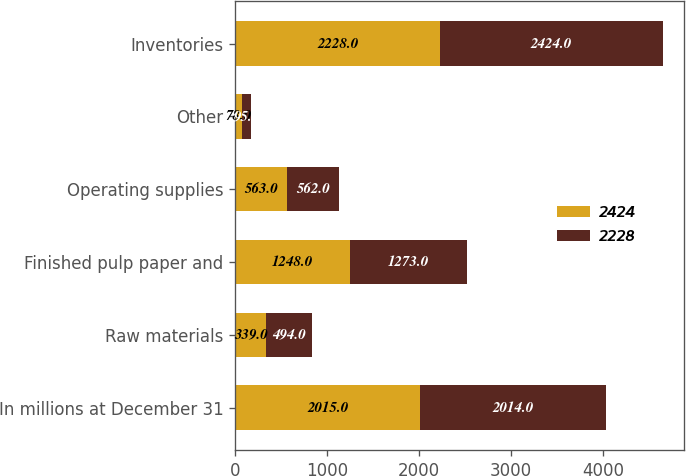Convert chart to OTSL. <chart><loc_0><loc_0><loc_500><loc_500><stacked_bar_chart><ecel><fcel>In millions at December 31<fcel>Raw materials<fcel>Finished pulp paper and<fcel>Operating supplies<fcel>Other<fcel>Inventories<nl><fcel>2424<fcel>2015<fcel>339<fcel>1248<fcel>563<fcel>78<fcel>2228<nl><fcel>2228<fcel>2014<fcel>494<fcel>1273<fcel>562<fcel>95<fcel>2424<nl></chart> 